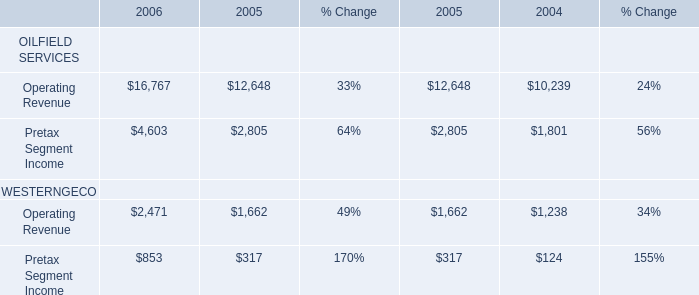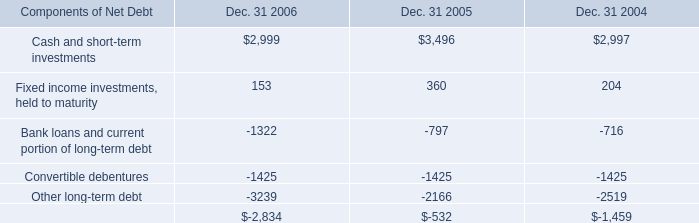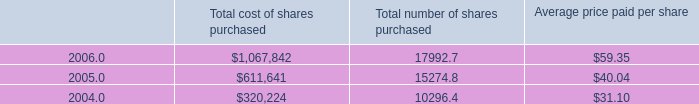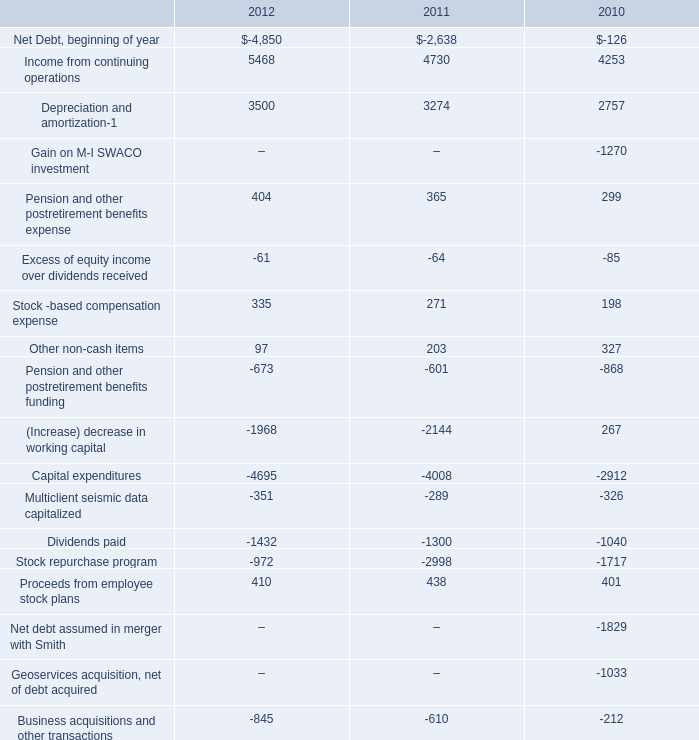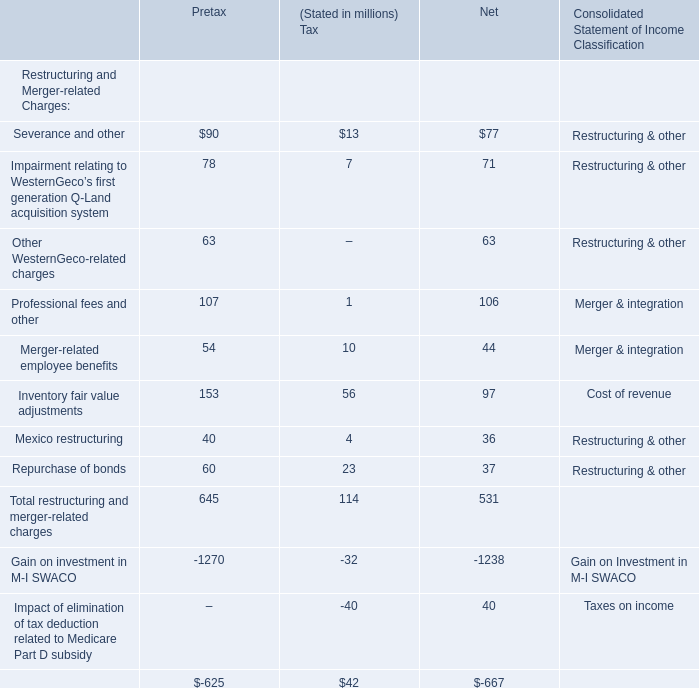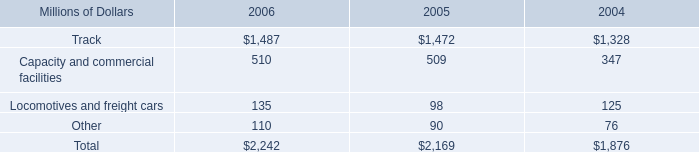what was the percentage change in cash capital investments in track from 2005 to 2006? 
Computations: ((1487 - 1472) / 1472)
Answer: 0.01019. 